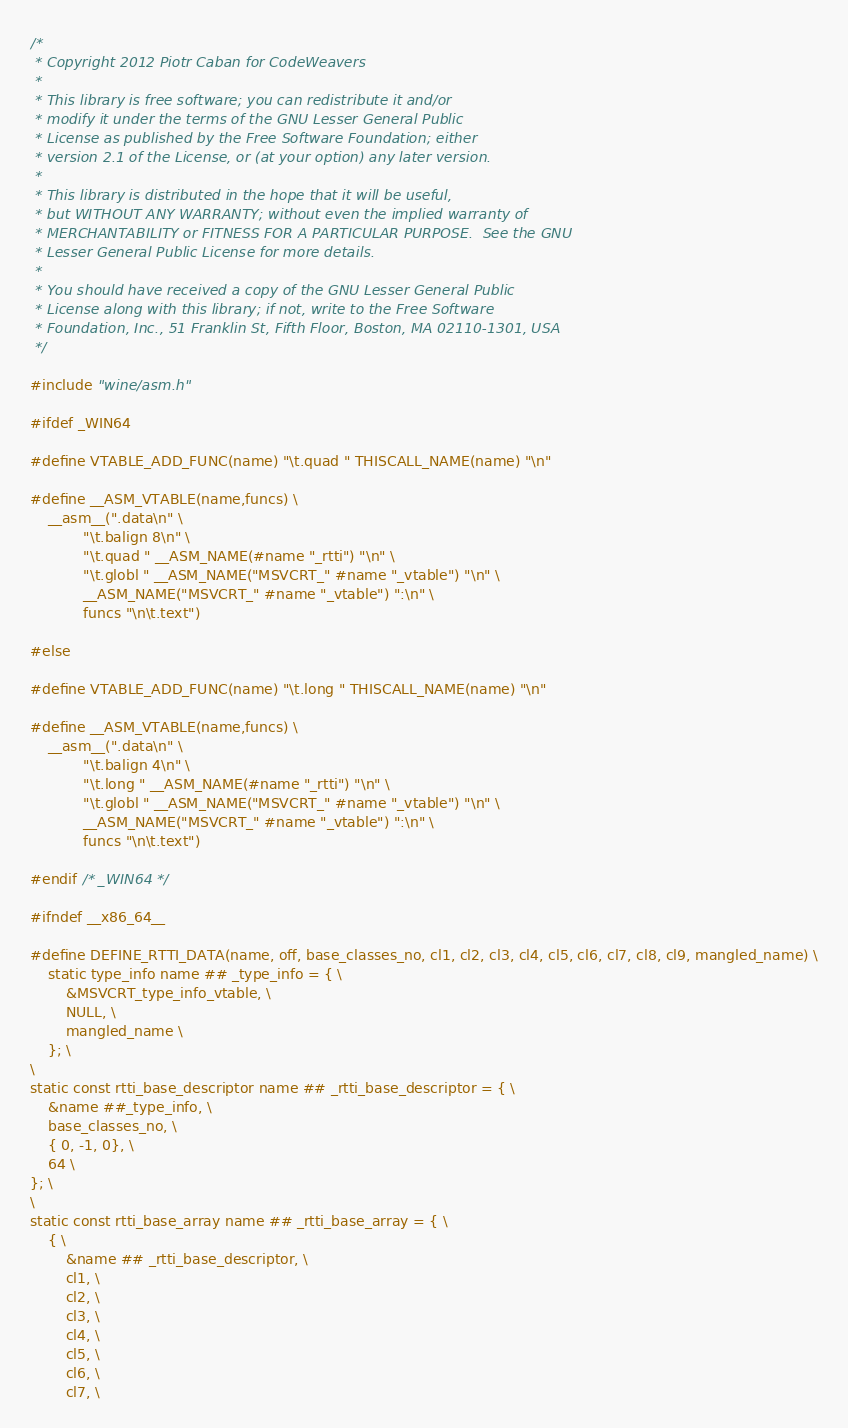<code> <loc_0><loc_0><loc_500><loc_500><_C_>/*
 * Copyright 2012 Piotr Caban for CodeWeavers
 *
 * This library is free software; you can redistribute it and/or
 * modify it under the terms of the GNU Lesser General Public
 * License as published by the Free Software Foundation; either
 * version 2.1 of the License, or (at your option) any later version.
 *
 * This library is distributed in the hope that it will be useful,
 * but WITHOUT ANY WARRANTY; without even the implied warranty of
 * MERCHANTABILITY or FITNESS FOR A PARTICULAR PURPOSE.  See the GNU
 * Lesser General Public License for more details.
 *
 * You should have received a copy of the GNU Lesser General Public
 * License along with this library; if not, write to the Free Software
 * Foundation, Inc., 51 Franklin St, Fifth Floor, Boston, MA 02110-1301, USA
 */

#include "wine/asm.h"

#ifdef _WIN64

#define VTABLE_ADD_FUNC(name) "\t.quad " THISCALL_NAME(name) "\n"

#define __ASM_VTABLE(name,funcs) \
    __asm__(".data\n" \
            "\t.balign 8\n" \
            "\t.quad " __ASM_NAME(#name "_rtti") "\n" \
            "\t.globl " __ASM_NAME("MSVCRT_" #name "_vtable") "\n" \
            __ASM_NAME("MSVCRT_" #name "_vtable") ":\n" \
            funcs "\n\t.text")

#else

#define VTABLE_ADD_FUNC(name) "\t.long " THISCALL_NAME(name) "\n"

#define __ASM_VTABLE(name,funcs) \
    __asm__(".data\n" \
            "\t.balign 4\n" \
            "\t.long " __ASM_NAME(#name "_rtti") "\n" \
            "\t.globl " __ASM_NAME("MSVCRT_" #name "_vtable") "\n" \
            __ASM_NAME("MSVCRT_" #name "_vtable") ":\n" \
            funcs "\n\t.text")

#endif /* _WIN64 */

#ifndef __x86_64__

#define DEFINE_RTTI_DATA(name, off, base_classes_no, cl1, cl2, cl3, cl4, cl5, cl6, cl7, cl8, cl9, mangled_name) \
    static type_info name ## _type_info = { \
        &MSVCRT_type_info_vtable, \
        NULL, \
        mangled_name \
    }; \
\
static const rtti_base_descriptor name ## _rtti_base_descriptor = { \
    &name ##_type_info, \
    base_classes_no, \
    { 0, -1, 0}, \
    64 \
}; \
\
static const rtti_base_array name ## _rtti_base_array = { \
    { \
        &name ## _rtti_base_descriptor, \
        cl1, \
        cl2, \
        cl3, \
        cl4, \
        cl5, \
        cl6, \
        cl7, \</code> 